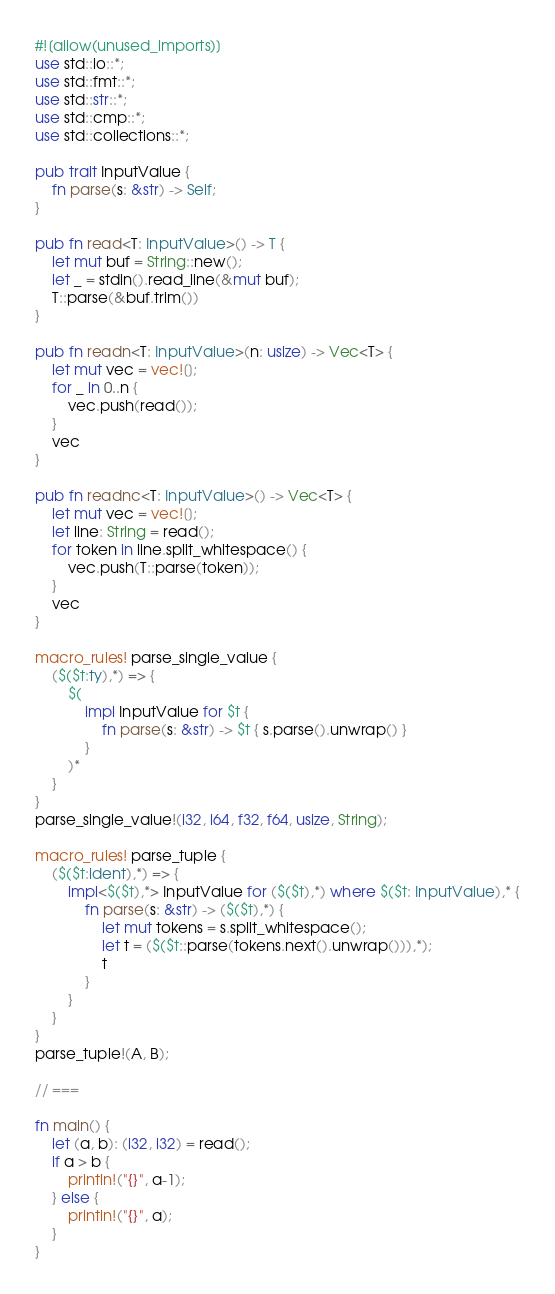<code> <loc_0><loc_0><loc_500><loc_500><_Rust_>#![allow(unused_imports)]
use std::io::*;
use std::fmt::*;
use std::str::*;
use std::cmp::*;
use std::collections::*;

pub trait InputValue {
    fn parse(s: &str) -> Self;
}

pub fn read<T: InputValue>() -> T {
    let mut buf = String::new();
    let _ = stdin().read_line(&mut buf);
    T::parse(&buf.trim())
}

pub fn readn<T: InputValue>(n: usize) -> Vec<T> {
    let mut vec = vec![];
    for _ in 0..n {
        vec.push(read());
    }
    vec
}

pub fn readnc<T: InputValue>() -> Vec<T> {
    let mut vec = vec![];
    let line: String = read();
    for token in line.split_whitespace() {
        vec.push(T::parse(token));
    }
    vec
}

macro_rules! parse_single_value {
    ($($t:ty),*) => {
        $(
            impl InputValue for $t {
                fn parse(s: &str) -> $t { s.parse().unwrap() }
            }
        )*
	}
}
parse_single_value!(i32, i64, f32, f64, usize, String);

macro_rules! parse_tuple {
	($($t:ident),*) => {
		impl<$($t),*> InputValue for ($($t),*) where $($t: InputValue),* {
			fn parse(s: &str) -> ($($t),*) {
				let mut tokens = s.split_whitespace();
				let t = ($($t::parse(tokens.next().unwrap())),*);
				t
			}
		}
	}
}
parse_tuple!(A, B);

// ===

fn main() {
    let (a, b): (i32, i32) = read();
    if a > b {
        println!("{}", a-1);
    } else {
        println!("{}", a);
    }
}

</code> 